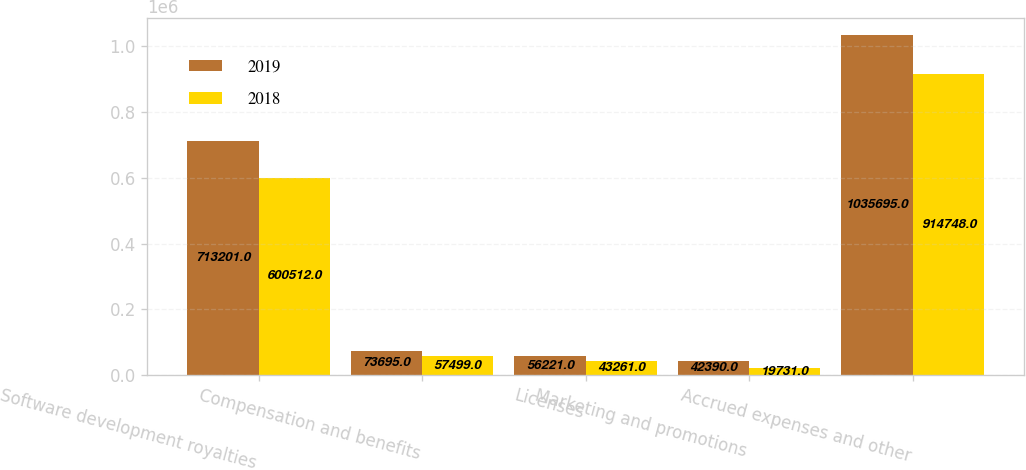<chart> <loc_0><loc_0><loc_500><loc_500><stacked_bar_chart><ecel><fcel>Software development royalties<fcel>Compensation and benefits<fcel>Licenses<fcel>Marketing and promotions<fcel>Accrued expenses and other<nl><fcel>2019<fcel>713201<fcel>73695<fcel>56221<fcel>42390<fcel>1.0357e+06<nl><fcel>2018<fcel>600512<fcel>57499<fcel>43261<fcel>19731<fcel>914748<nl></chart> 